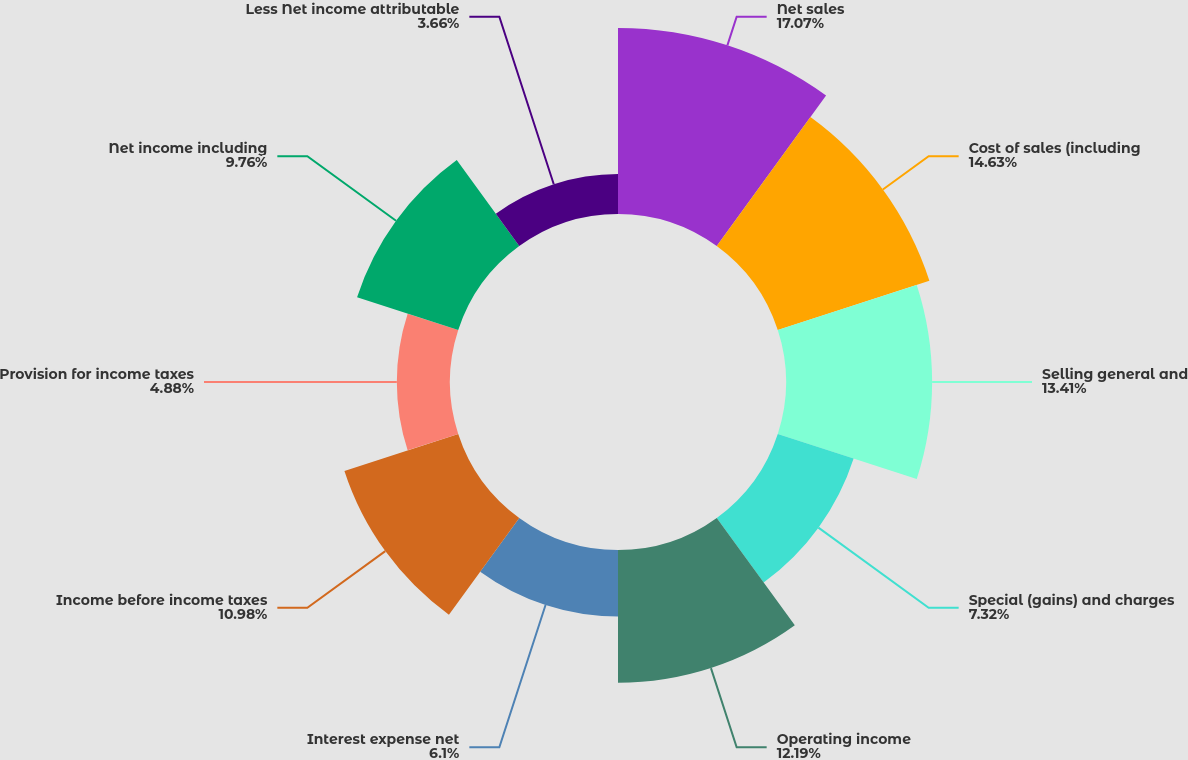<chart> <loc_0><loc_0><loc_500><loc_500><pie_chart><fcel>Net sales<fcel>Cost of sales (including<fcel>Selling general and<fcel>Special (gains) and charges<fcel>Operating income<fcel>Interest expense net<fcel>Income before income taxes<fcel>Provision for income taxes<fcel>Net income including<fcel>Less Net income attributable<nl><fcel>17.07%<fcel>14.63%<fcel>13.41%<fcel>7.32%<fcel>12.19%<fcel>6.1%<fcel>10.98%<fcel>4.88%<fcel>9.76%<fcel>3.66%<nl></chart> 